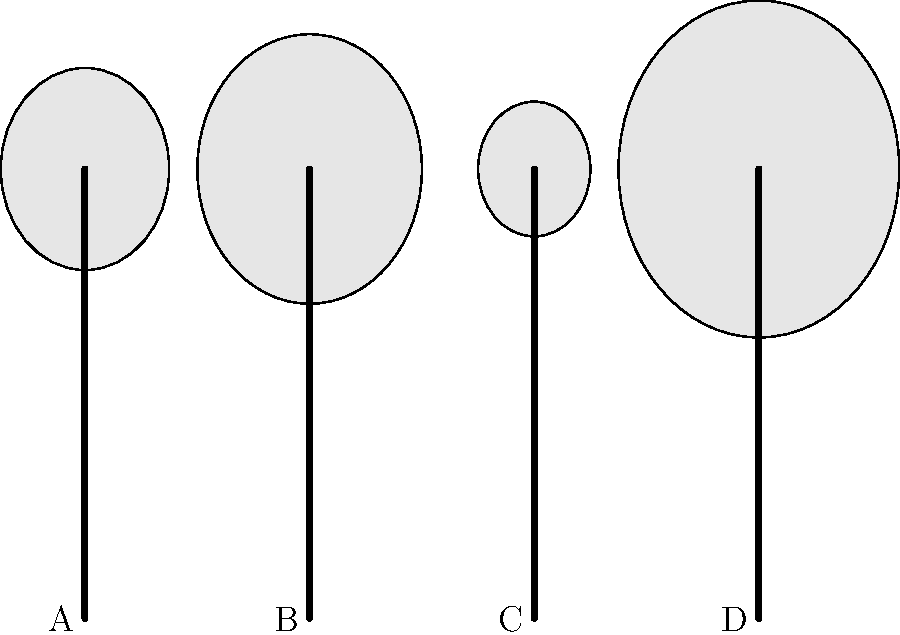As a British amateur kayaker representing local talent, you're preparing for a competition. Identify the paddle type that would be most suitable for whitewater kayaking based on the blade shapes shown in the diagram. Let's analyze each paddle type based on their blade shapes:

1. Paddle A: Medium-sized blade, balanced shape. This is likely a touring or recreational paddle.

2. Paddle B: Wider blade with a more pronounced shape. This design is typical for whitewater kayaking paddles.

3. Paddle C: Narrow blade with a streamlined shape. This design is commonly used for racing or long-distance paddling.

4. Paddle D: Extra-wide blade, which is not typical for standard kayaking and might be used for specialized purposes or canoeing.

For whitewater kayaking, you need a paddle that provides good control and power in turbulent waters. The wider blade of Paddle B offers more surface area, allowing for stronger strokes and better maneuverability in rapids. This design helps with quick turns and bracing, which are essential techniques in whitewater kayaking.

Therefore, Paddle B would be the most suitable choice for whitewater kayaking among the options presented.
Answer: Paddle B 